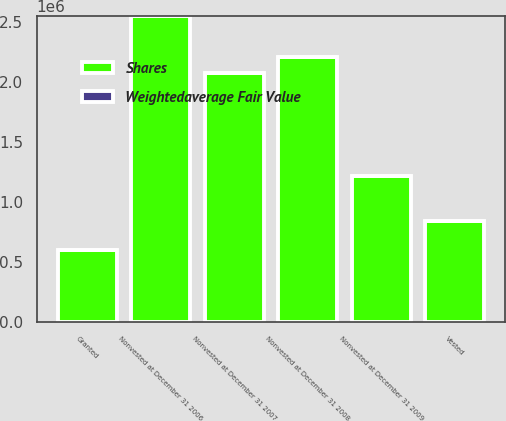<chart> <loc_0><loc_0><loc_500><loc_500><stacked_bar_chart><ecel><fcel>Nonvested at December 31 2006<fcel>Granted<fcel>Nonvested at December 31 2007<fcel>Vested<fcel>Nonvested at December 31 2008<fcel>Nonvested at December 31 2009<nl><fcel>Shares<fcel>2.54518e+06<fcel>597240<fcel>2.07464e+06<fcel>842300<fcel>2.20649e+06<fcel>1.21339e+06<nl><fcel>Weightedaverage Fair Value<fcel>17.8<fcel>38.21<fcel>26.34<fcel>19.08<fcel>32.98<fcel>40.63<nl></chart> 